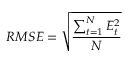<formula> <loc_0><loc_0><loc_500><loc_500>\ R M S E = { \sqrt { \frac { \sum _ { t = 1 } ^ { N } { E _ { t } ^ { 2 } } } { N } } }</formula> 